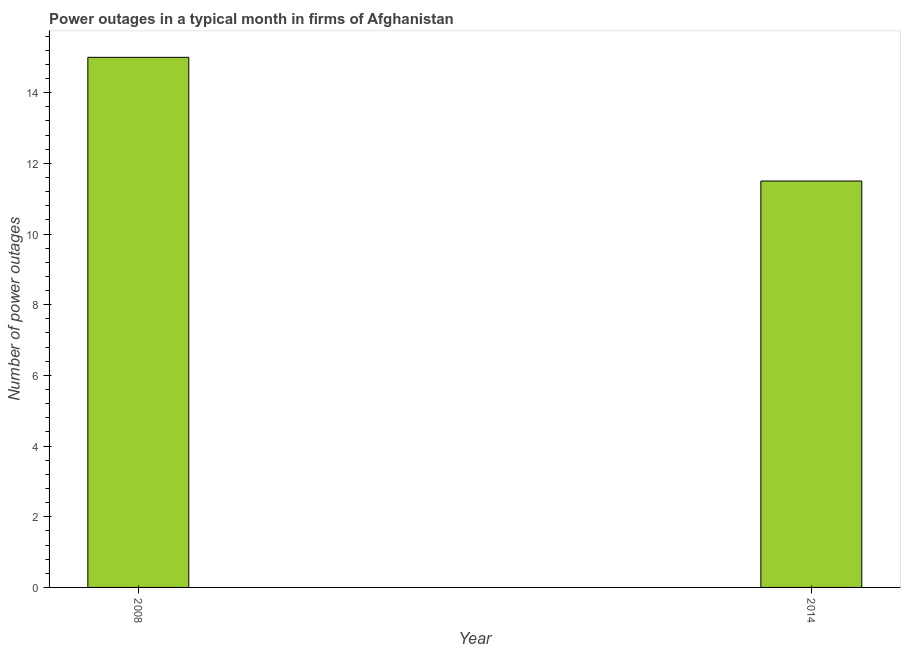Does the graph contain grids?
Your response must be concise. No. What is the title of the graph?
Ensure brevity in your answer.  Power outages in a typical month in firms of Afghanistan. What is the label or title of the Y-axis?
Your answer should be compact. Number of power outages. What is the number of power outages in 2008?
Your answer should be very brief. 15. Across all years, what is the minimum number of power outages?
Provide a short and direct response. 11.5. In which year was the number of power outages maximum?
Your answer should be compact. 2008. In which year was the number of power outages minimum?
Provide a succinct answer. 2014. What is the sum of the number of power outages?
Offer a terse response. 26.5. What is the difference between the number of power outages in 2008 and 2014?
Offer a terse response. 3.5. What is the average number of power outages per year?
Your response must be concise. 13.25. What is the median number of power outages?
Your answer should be compact. 13.25. In how many years, is the number of power outages greater than 7.6 ?
Ensure brevity in your answer.  2. What is the ratio of the number of power outages in 2008 to that in 2014?
Provide a short and direct response. 1.3. How many bars are there?
Give a very brief answer. 2. Are all the bars in the graph horizontal?
Keep it short and to the point. No. What is the difference between the Number of power outages in 2008 and 2014?
Provide a short and direct response. 3.5. What is the ratio of the Number of power outages in 2008 to that in 2014?
Give a very brief answer. 1.3. 